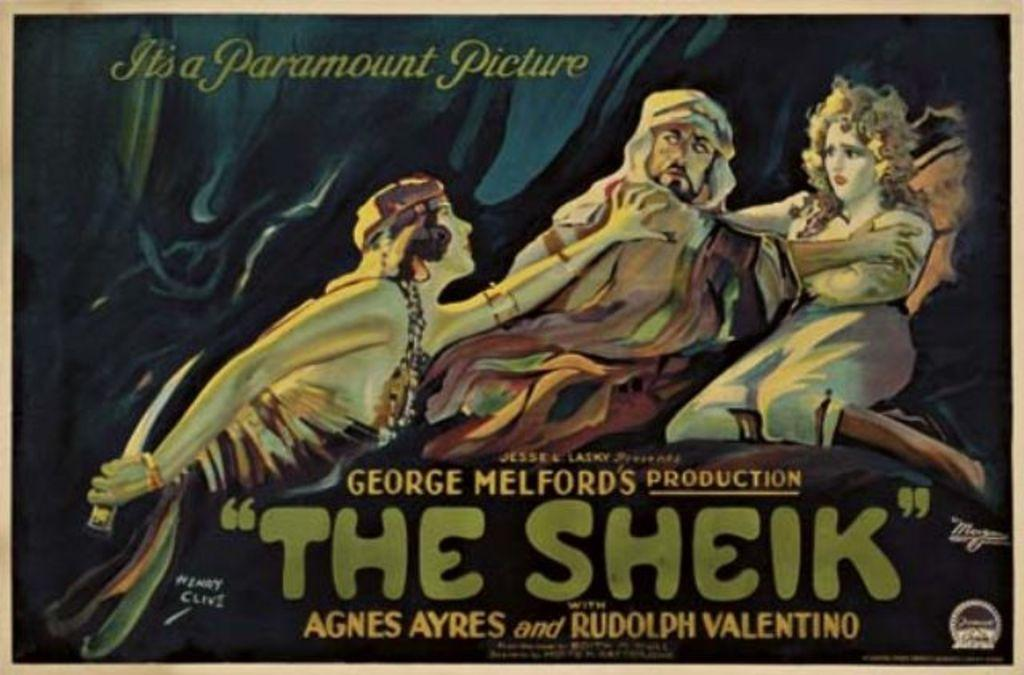<image>
Share a concise interpretation of the image provided. a photo of a character called The Sheik 